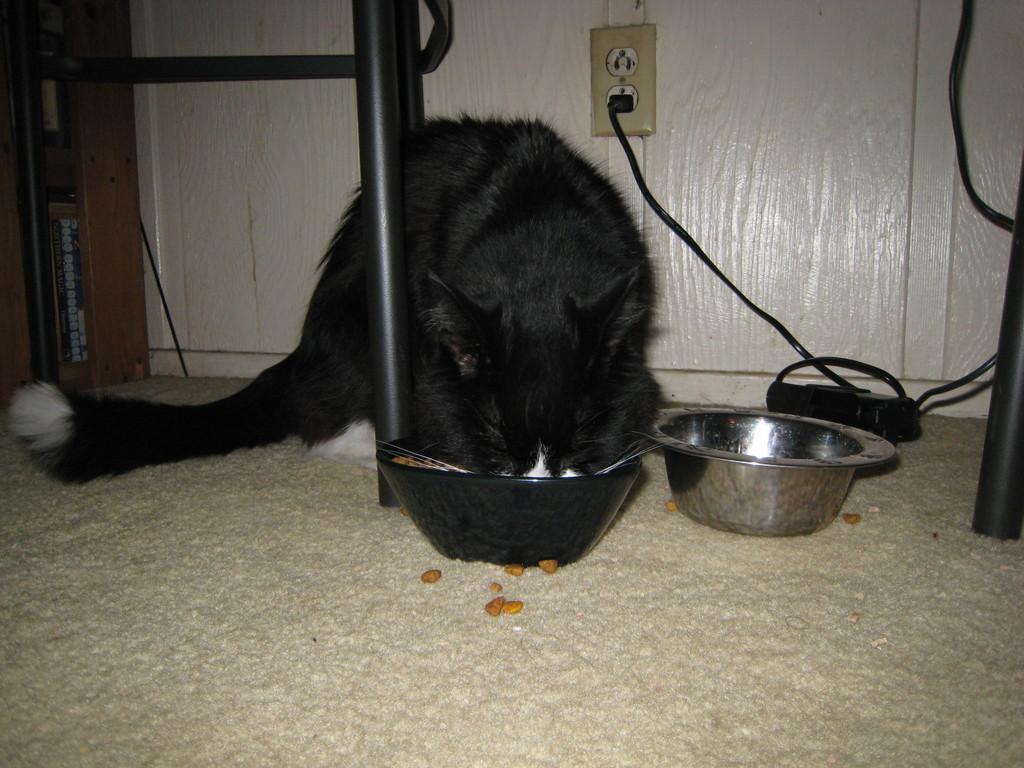How would you summarize this image in a sentence or two? In this image I can see the cream colored floor, two bowls, the cream colored wall , a electric socket and a black colored wire. I can see a cat which is black and white in color. I can see few black colored objects. 